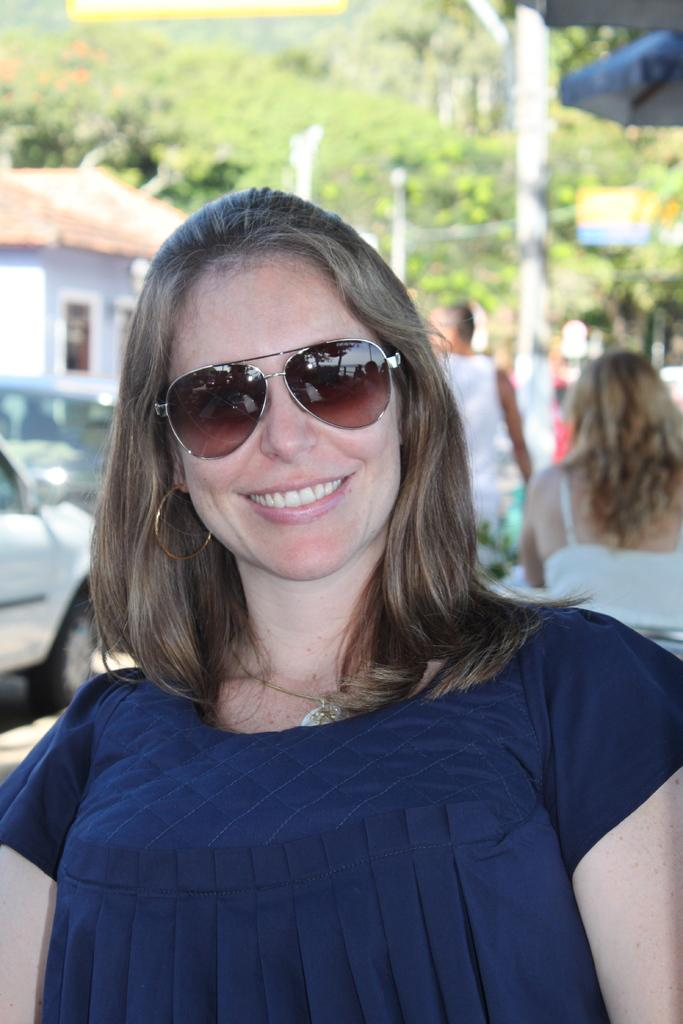Who is the main subject in the foreground of the image? There is a woman in the foreground of the image. What is the woman wearing on her face? The woman is wearing goggles. What expression does the woman have in the image? The woman is smiling. What can be seen in the background of the image? There are vehicles, a house, trees, and other people visible in the background of the image. What color is the crayon that the woman is holding in the image? There is no crayon present in the image; the woman is wearing goggles and smiling. 